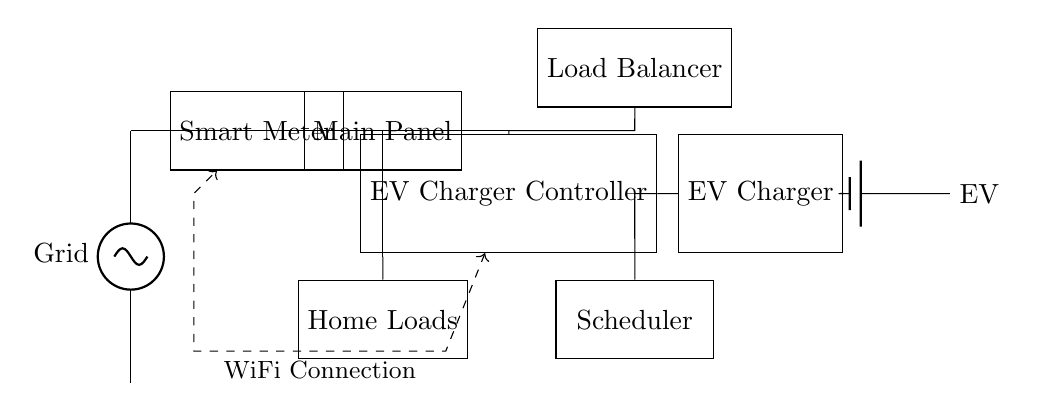What is the primary input source to the circuit? The primary input source is labeled as "Grid," indicating that the circuit relies on electrical energy from the grid.
Answer: Grid What component is responsible for managing electricity going to the EV charger? The component managing the electricity flow to the EV charger is the "EV Charger Controller," which regulates the charging process.
Answer: EV Charger Controller What does the "Load Balancer" do in this circuit? The Load Balancer distributes the available electrical load efficiently across multiple connected devices to prevent overload and optimize usage.
Answer: Distributes load How many main components are connected after the Smart Meter? There are three main components connected after the Smart Meter: the Main Panel, the EV Charger Controller, and the Home Loads.
Answer: Three Which component allows for scheduled charging times? The component that facilitates scheduled charging times is the "Scheduler," which manages when charging occurs based on preset criteria or user preferences.
Answer: Scheduler What type of communication is depicted in the circuit diagram? The circuit diagram shows a WiFi Connection, which allows for wireless communication between components, specifically from the controller to the smart meter.
Answer: WiFi Connection Where does the EV connect in the circuit? The EV connects at the end of the circuit to the "EV Charger," which supplies the necessary power to charge the vehicle's battery.
Answer: EV Charger 